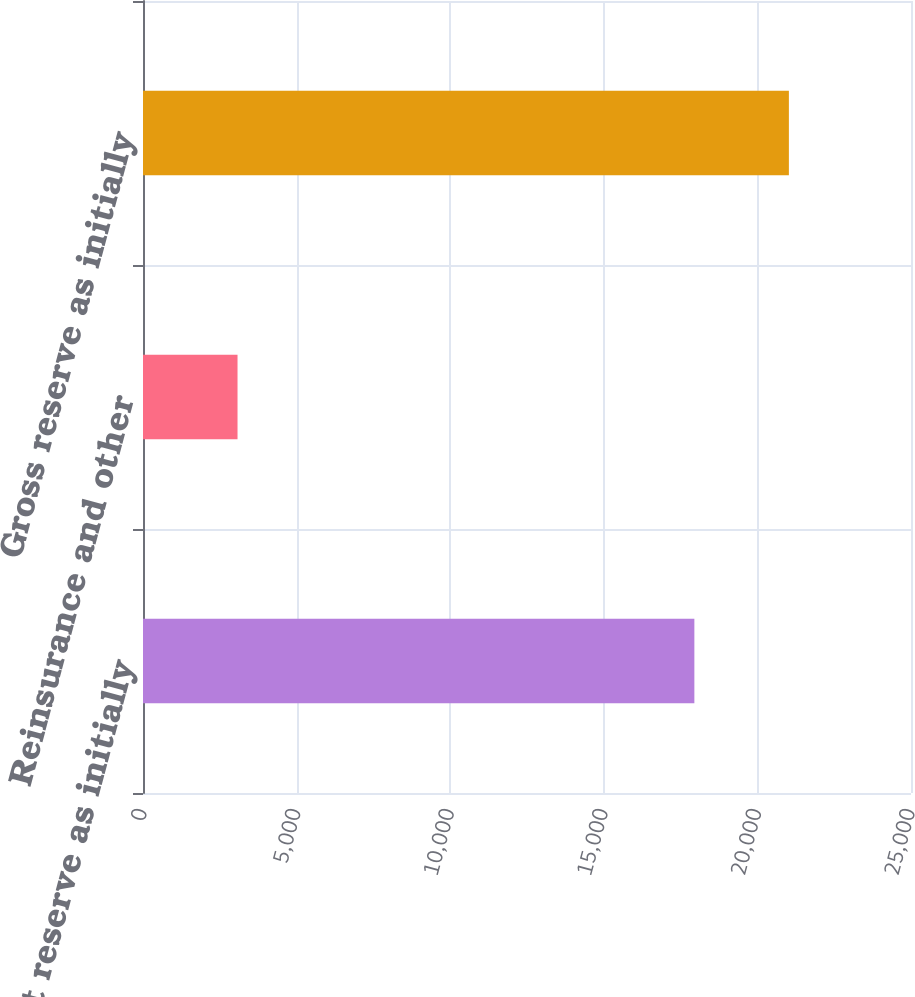<chart> <loc_0><loc_0><loc_500><loc_500><bar_chart><fcel>Net reserve as initially<fcel>Reinsurance and other<fcel>Gross reserve as initially<nl><fcel>17948<fcel>3077<fcel>21025<nl></chart> 